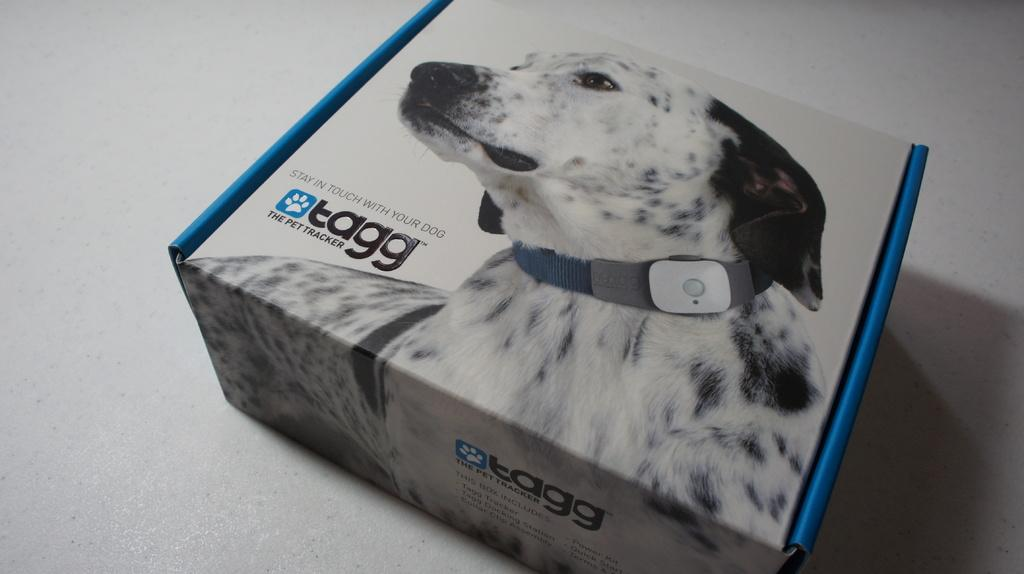<image>
Create a compact narrative representing the image presented. a box with a spotted dog wearing a TAGG collar 